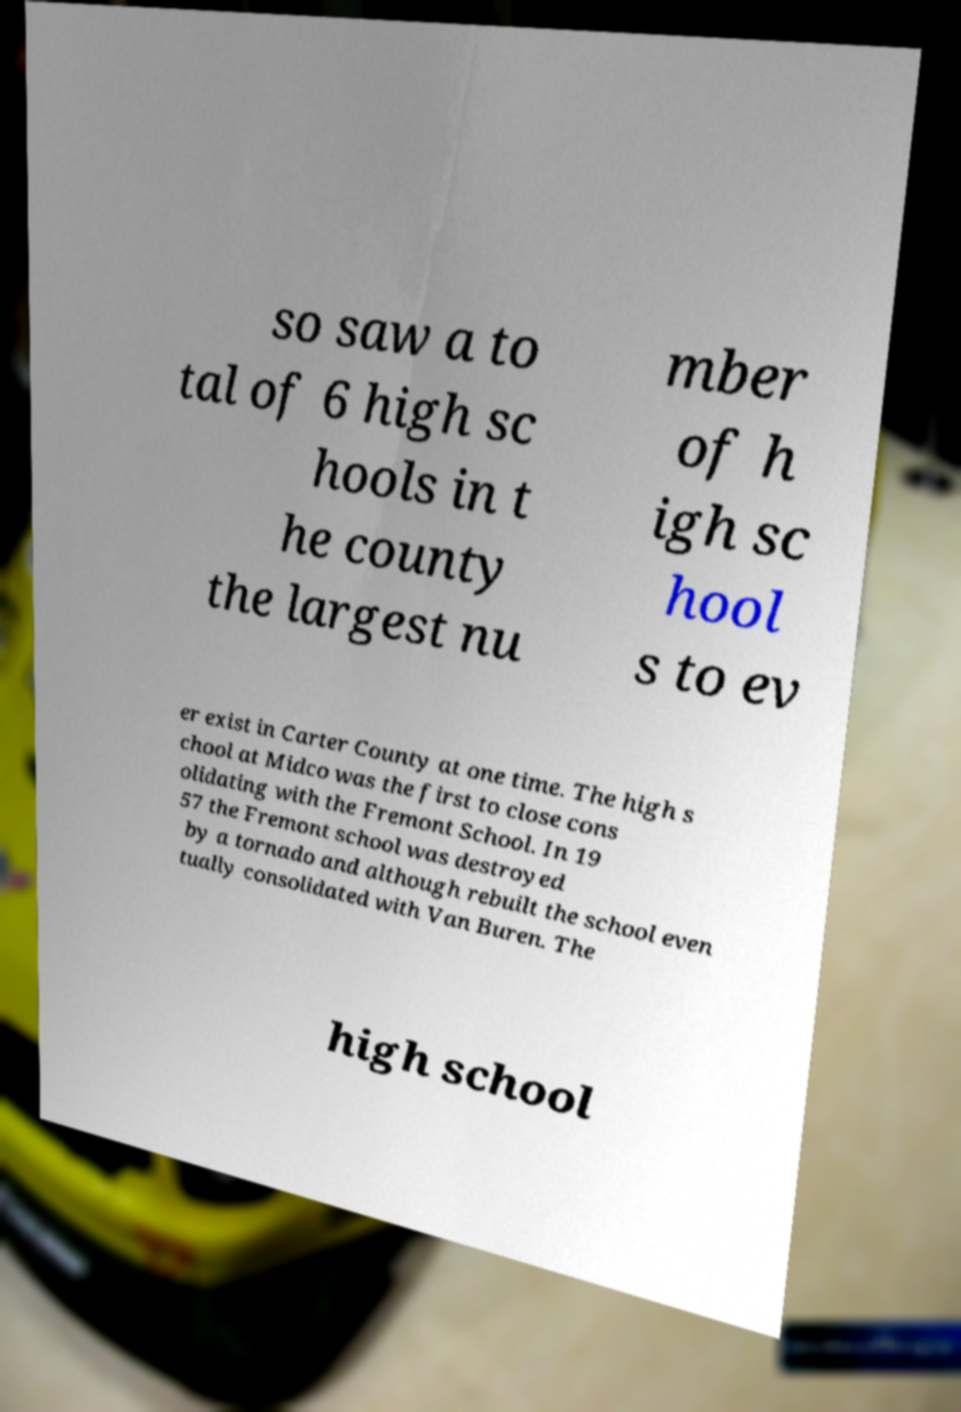Can you accurately transcribe the text from the provided image for me? so saw a to tal of 6 high sc hools in t he county the largest nu mber of h igh sc hool s to ev er exist in Carter County at one time. The high s chool at Midco was the first to close cons olidating with the Fremont School. In 19 57 the Fremont school was destroyed by a tornado and although rebuilt the school even tually consolidated with Van Buren. The high school 